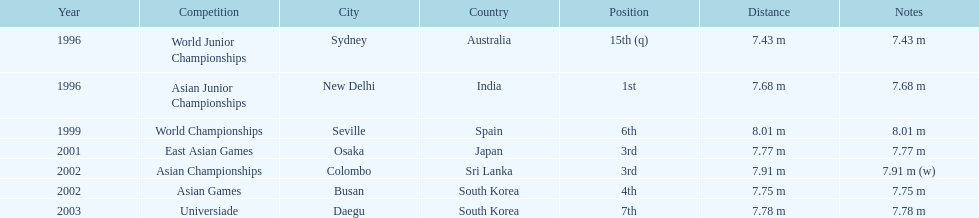In what year was the position of 3rd first achieved? 2001. 